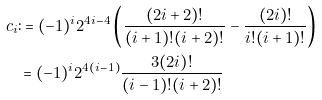Convert formula to latex. <formula><loc_0><loc_0><loc_500><loc_500>c _ { i } & \colon = ( - 1 ) ^ { i } 2 ^ { 4 i - 4 } \left ( \frac { ( 2 i + 2 ) ! } { ( i + 1 ) ! ( i + 2 ) ! } - \frac { ( 2 i ) ! } { i ! ( i + 1 ) ! } \right ) \\ & = ( - 1 ) ^ { i } 2 ^ { 4 ( i - 1 ) } \frac { 3 ( 2 i ) ! } { ( i - 1 ) ! ( i + 2 ) ! }</formula> 